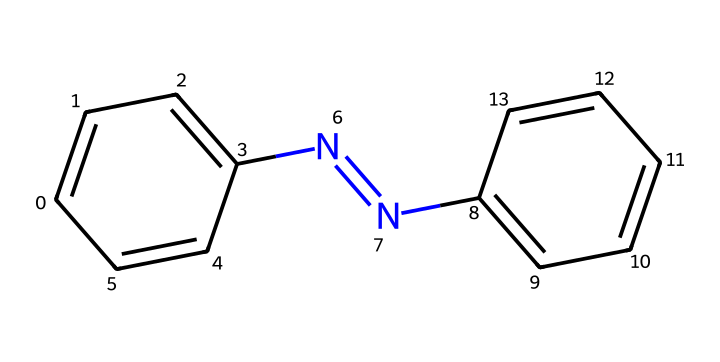What is the formula of azobenzene? The SMILES representation shows two aromatic rings (indicated by 'c' and 'cc'), along with a nitrogen-nitrogen double bond (indicated by 'N=N'). The atoms involved are carbon (C), hydrogen (H), and nitrogen (N). The formula can be deduced as C12H10N2.
Answer: C12H10N2 How many carbon atoms are present in azobenzene? By examining the chemical structure, there are two aromatic rings, each contributing six carbon atoms, leading to a total of twelve carbon atoms.
Answer: 12 What type of compound is azobenzene? Azobenzene consists of two phenyl groups connected by a nitrogen-nitrogen double bond, classifying it as an azo compound.
Answer: azo compound What is the significance of the N=N bond in azobenzene? The nitrogen-nitrogen double bond (N=N) in azobenzene plays a crucial role in its photochromic properties, as it allows for isomerization upon exposure to light.
Answer: photochromic properties Which functional groups are present in azobenzene? The presence of the nitrogen-nitrogen double bond and the aromatic rings indicate that azobenzene contains both azo and aromatic functional groups.
Answer: azo, aromatic How does azobenzene change upon light exposure? Upon light exposure, azobenzene undergoes a cis-trans isomerization due to the N=N bond, leading to a change in its geometrical configuration, affecting its physical properties.
Answer: cis-trans isomerization What applications does azobenzene have in optical data storage? Azobenzene's ability to switch configurations with light enables it to be used in optical data storage as molecular switches, allowing for data encoding and access.
Answer: molecular switches 